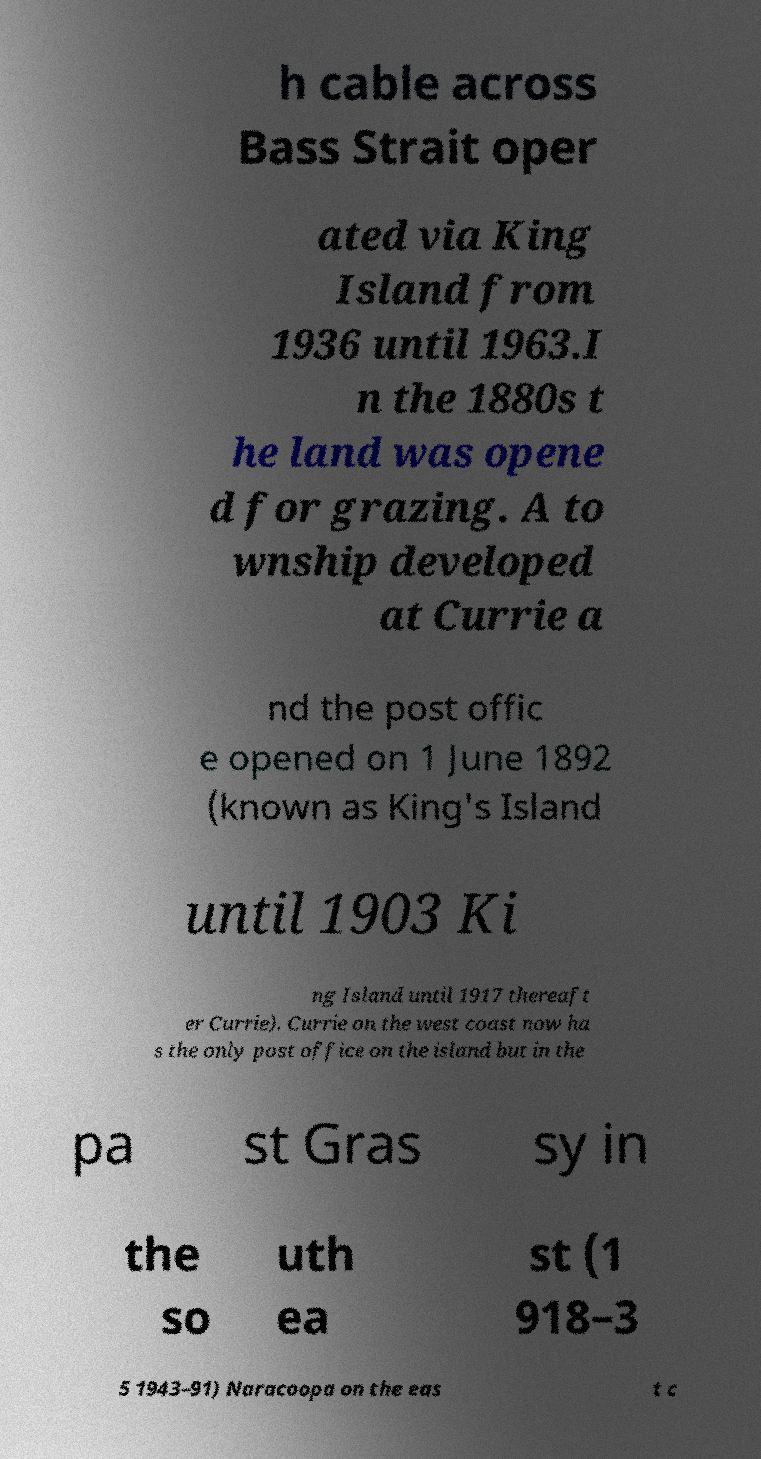Can you read and provide the text displayed in the image?This photo seems to have some interesting text. Can you extract and type it out for me? h cable across Bass Strait oper ated via King Island from 1936 until 1963.I n the 1880s t he land was opene d for grazing. A to wnship developed at Currie a nd the post offic e opened on 1 June 1892 (known as King's Island until 1903 Ki ng Island until 1917 thereaft er Currie). Currie on the west coast now ha s the only post office on the island but in the pa st Gras sy in the so uth ea st (1 918–3 5 1943–91) Naracoopa on the eas t c 